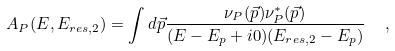Convert formula to latex. <formula><loc_0><loc_0><loc_500><loc_500>A _ { P } ( E , E _ { r e s , 2 } ) = \int d \vec { p } \frac { \nu _ { P } ( \vec { p } ) \nu _ { P } ^ { * } ( \vec { p } ) } { ( E - E _ { p } + i 0 ) ( E _ { r e s , 2 } - E _ { p } ) } \ \ ,</formula> 